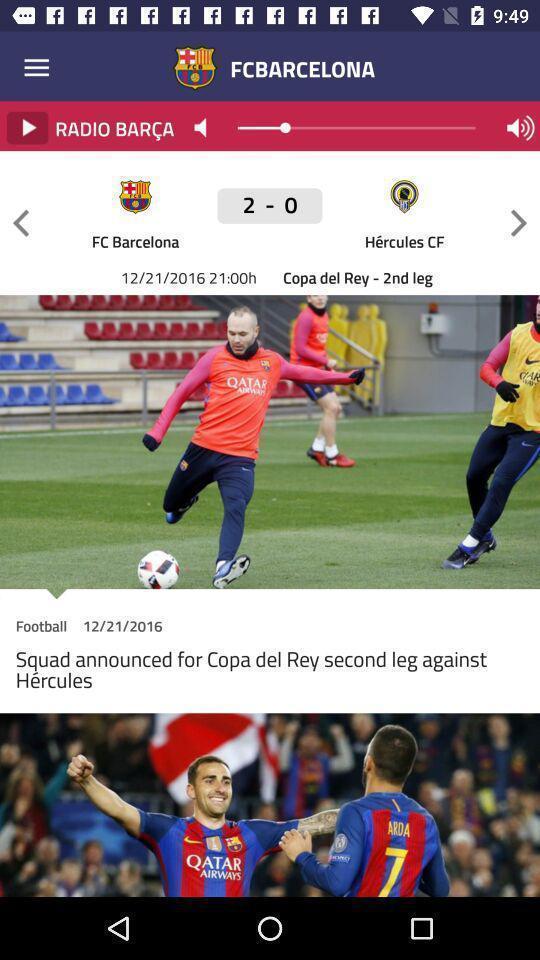What details can you identify in this image? Page that displaying sports application. 